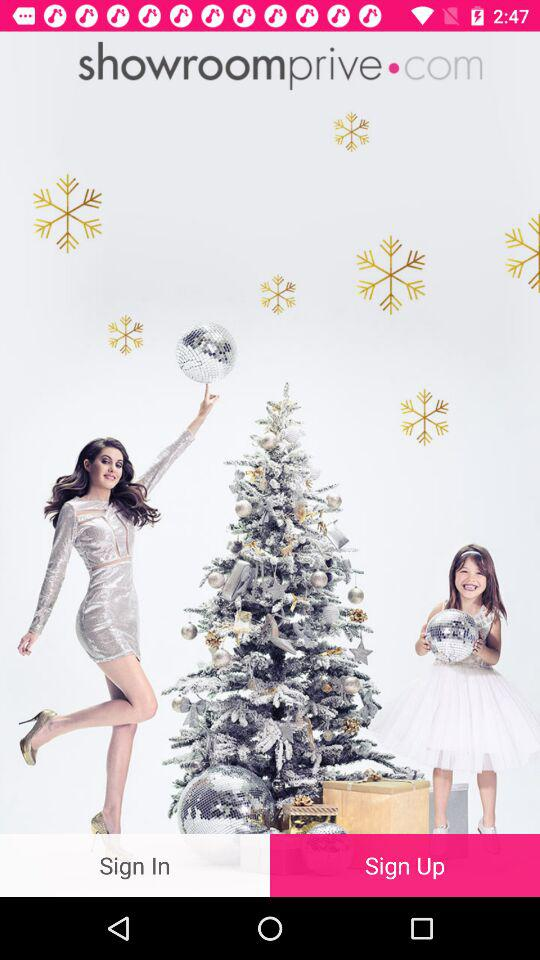What is the name of the application? The name of the application is "showroomprive". 